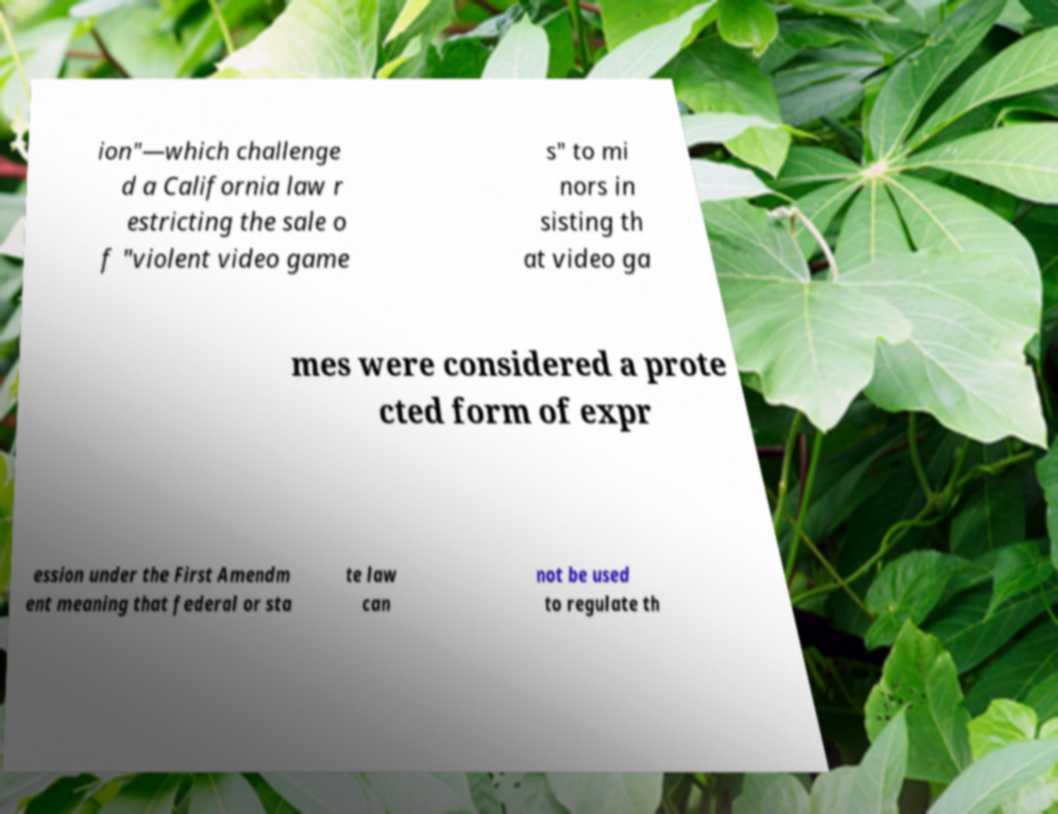I need the written content from this picture converted into text. Can you do that? ion"—which challenge d a California law r estricting the sale o f "violent video game s" to mi nors in sisting th at video ga mes were considered a prote cted form of expr ession under the First Amendm ent meaning that federal or sta te law can not be used to regulate th 